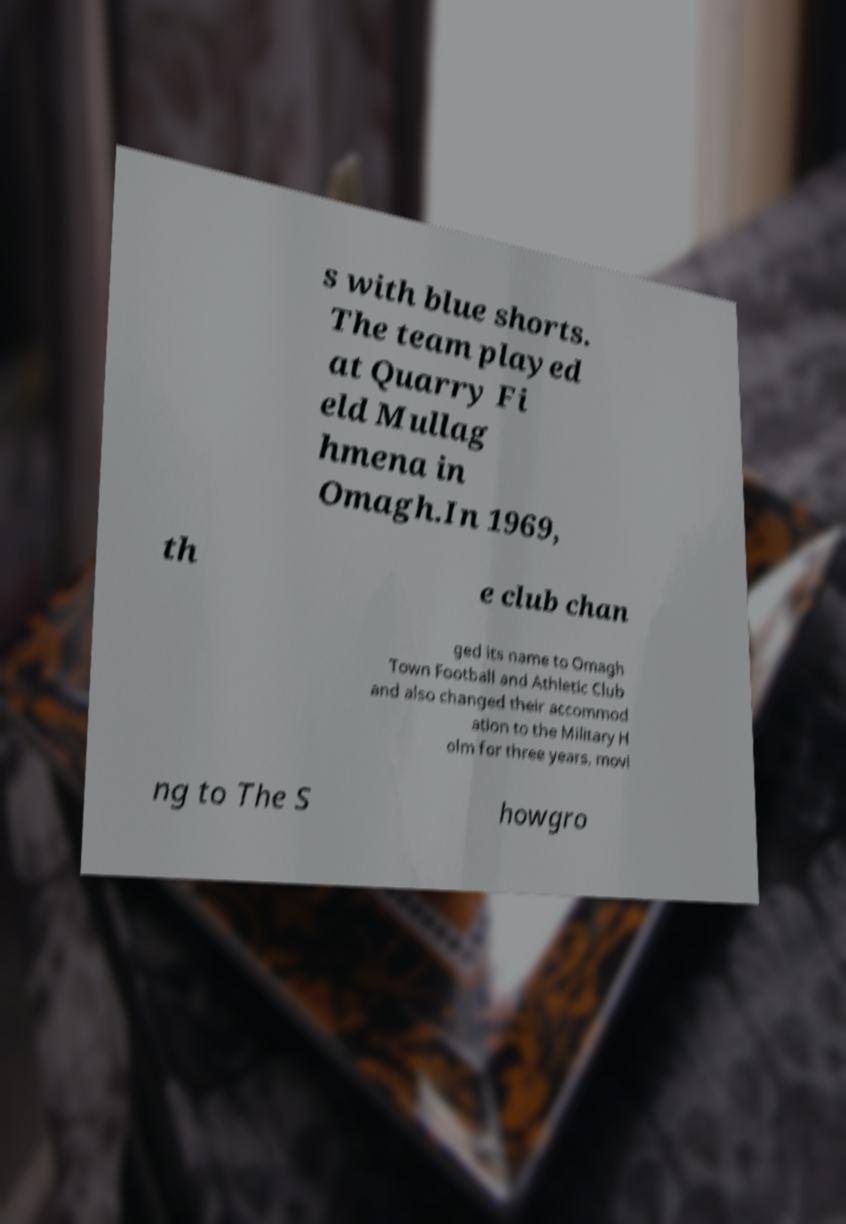I need the written content from this picture converted into text. Can you do that? s with blue shorts. The team played at Quarry Fi eld Mullag hmena in Omagh.In 1969, th e club chan ged its name to Omagh Town Football and Athletic Club and also changed their accommod ation to the Military H olm for three years, movi ng to The S howgro 